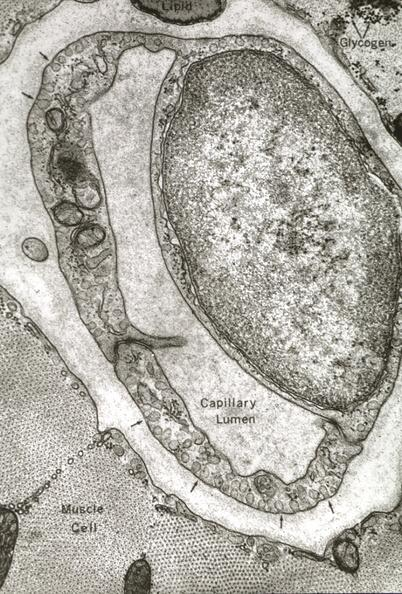s capillary present?
Answer the question using a single word or phrase. Yes 